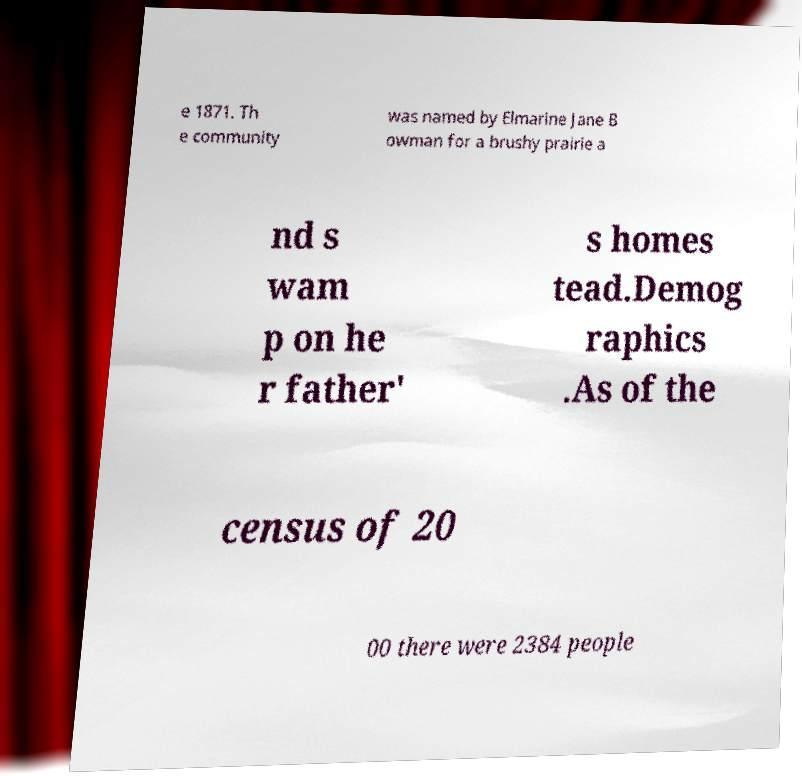Please read and relay the text visible in this image. What does it say? e 1871. Th e community was named by Elmarine Jane B owman for a brushy prairie a nd s wam p on he r father' s homes tead.Demog raphics .As of the census of 20 00 there were 2384 people 